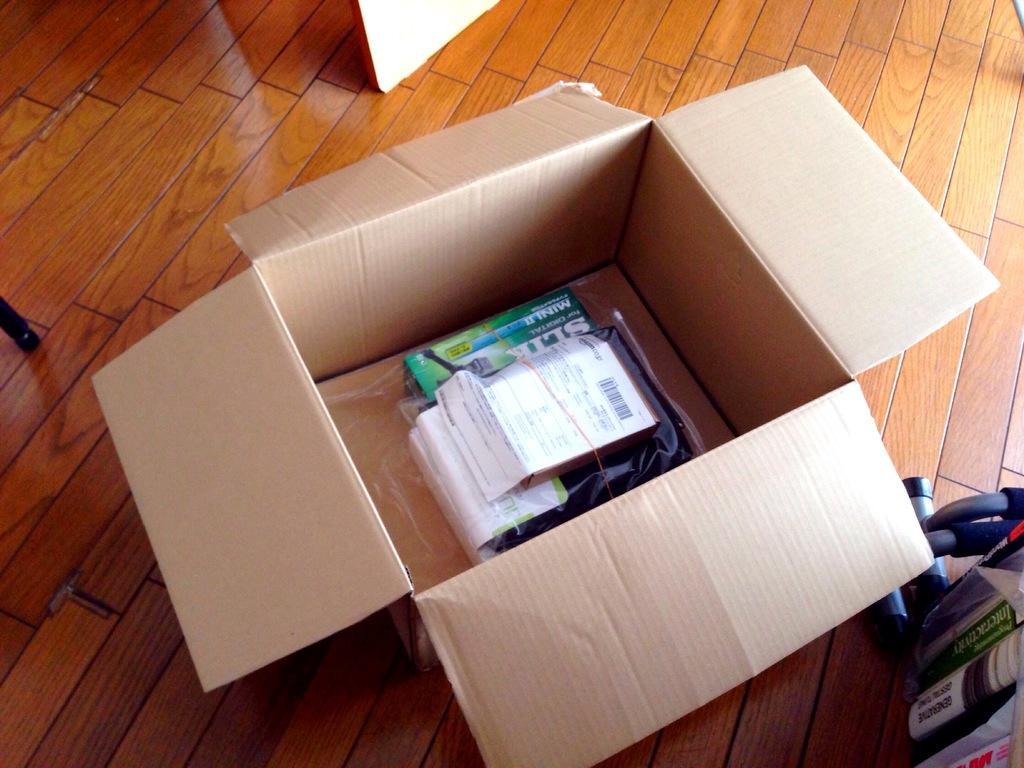How would you summarize this image in a sentence or two? In this image I can see few objects in the cardboard box. The box is on the brown color surface. To the right I can see the books. 